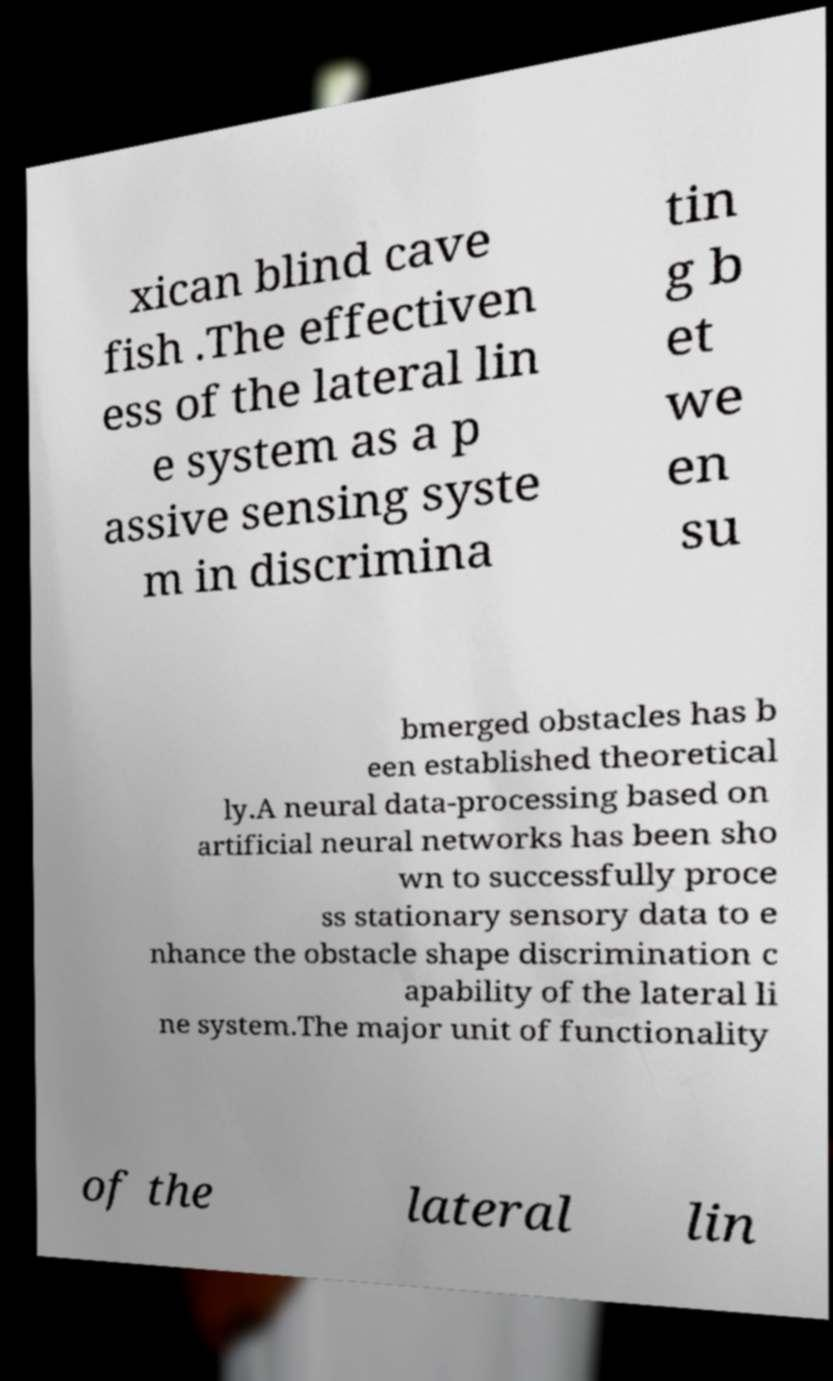I need the written content from this picture converted into text. Can you do that? xican blind cave fish .The effectiven ess of the lateral lin e system as a p assive sensing syste m in discrimina tin g b et we en su bmerged obstacles has b een established theoretical ly.A neural data-processing based on artificial neural networks has been sho wn to successfully proce ss stationary sensory data to e nhance the obstacle shape discrimination c apability of the lateral li ne system.The major unit of functionality of the lateral lin 